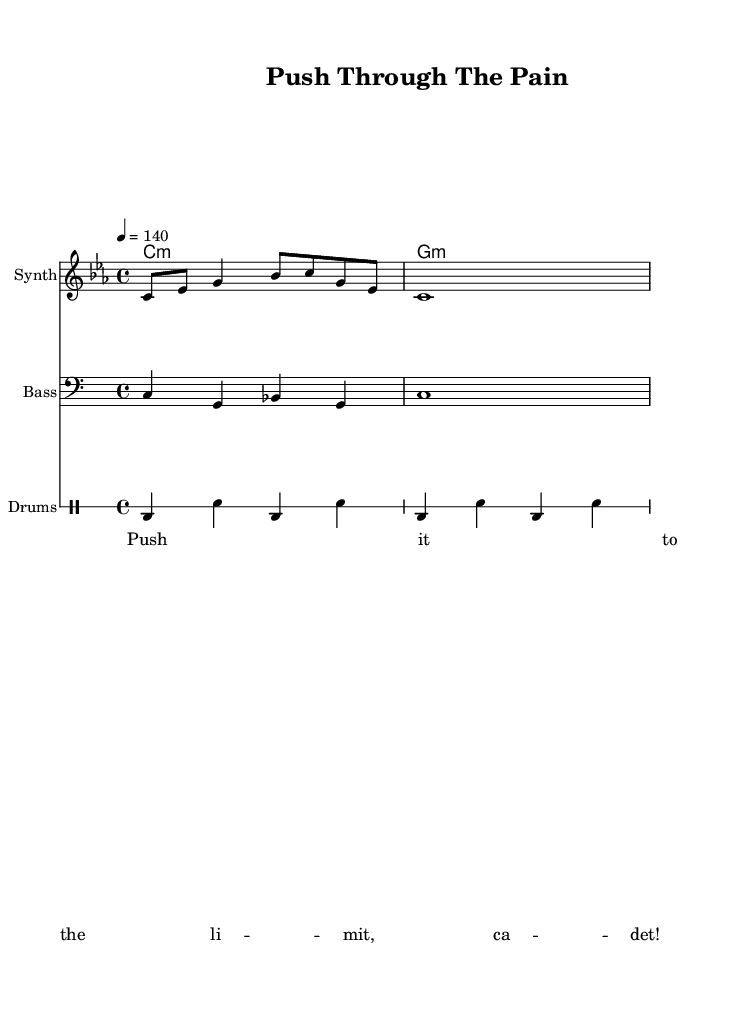What is the key signature of this music? The key signature is C minor, as indicated by the two flats (B♭ and E♭) shown in the key signature section.
Answer: C minor What is the time signature of this music? The time signature is 4/4, meaning there are four beats per measure and the quarter note gets one beat, which is stated at the beginning of the piece.
Answer: 4/4 What is the tempo marking of this track? The tempo is marked as 140 beats per minute, indicated by the marking "4 = 140" which shows the metronome setting.
Answer: 140 What instruments are featured in the score? The instruments included are Synth, Bass, and Drums, as each staff is labeled with the respective instrument names above it.
Answer: Synth, Bass, Drums How many measures does the melody contain? The melody consists of two measures, as indicated by the notes grouped within the measure bars on the staff.
Answer: 2 What is the primary lyrical message in the verse? The verse contains the motivational phrase "Push it to the limit, cadet!" which serves to inspire and encourage during a workout.
Answer: Push it to the limit, cadet! What style of music is this sheet representing? This sheet represents a Rap style of music, identifiable by the rhythmic nature, lyrical content, and inference from the title "Push Through The Pain."
Answer: Rap 